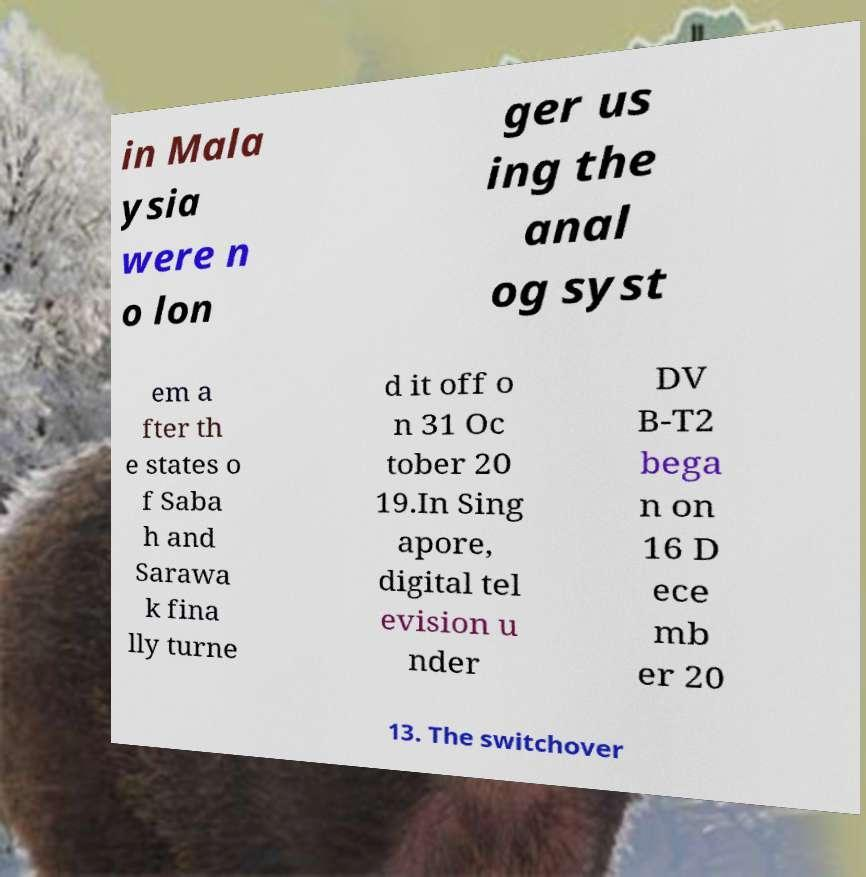Can you read and provide the text displayed in the image?This photo seems to have some interesting text. Can you extract and type it out for me? in Mala ysia were n o lon ger us ing the anal og syst em a fter th e states o f Saba h and Sarawa k fina lly turne d it off o n 31 Oc tober 20 19.In Sing apore, digital tel evision u nder DV B-T2 bega n on 16 D ece mb er 20 13. The switchover 